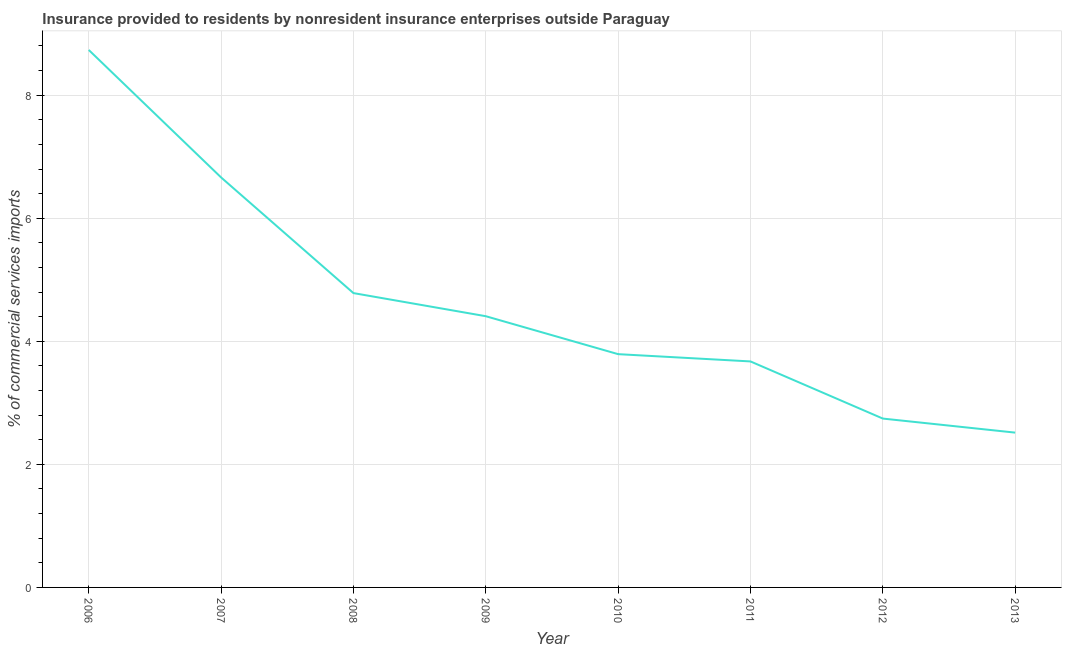What is the insurance provided by non-residents in 2013?
Offer a very short reply. 2.52. Across all years, what is the maximum insurance provided by non-residents?
Your response must be concise. 8.74. Across all years, what is the minimum insurance provided by non-residents?
Provide a succinct answer. 2.52. In which year was the insurance provided by non-residents minimum?
Offer a very short reply. 2013. What is the sum of the insurance provided by non-residents?
Offer a terse response. 37.32. What is the difference between the insurance provided by non-residents in 2006 and 2009?
Offer a terse response. 4.33. What is the average insurance provided by non-residents per year?
Give a very brief answer. 4.66. What is the median insurance provided by non-residents?
Offer a very short reply. 4.1. What is the ratio of the insurance provided by non-residents in 2006 to that in 2009?
Provide a succinct answer. 1.98. Is the insurance provided by non-residents in 2010 less than that in 2012?
Keep it short and to the point. No. What is the difference between the highest and the second highest insurance provided by non-residents?
Keep it short and to the point. 2.07. What is the difference between the highest and the lowest insurance provided by non-residents?
Provide a short and direct response. 6.22. How many years are there in the graph?
Make the answer very short. 8. What is the difference between two consecutive major ticks on the Y-axis?
Ensure brevity in your answer.  2. Are the values on the major ticks of Y-axis written in scientific E-notation?
Keep it short and to the point. No. Does the graph contain any zero values?
Your answer should be compact. No. Does the graph contain grids?
Keep it short and to the point. Yes. What is the title of the graph?
Your response must be concise. Insurance provided to residents by nonresident insurance enterprises outside Paraguay. What is the label or title of the Y-axis?
Your answer should be compact. % of commercial services imports. What is the % of commercial services imports in 2006?
Your response must be concise. 8.74. What is the % of commercial services imports in 2007?
Provide a short and direct response. 6.66. What is the % of commercial services imports of 2008?
Your answer should be compact. 4.78. What is the % of commercial services imports in 2009?
Your answer should be compact. 4.41. What is the % of commercial services imports of 2010?
Your response must be concise. 3.79. What is the % of commercial services imports in 2011?
Keep it short and to the point. 3.67. What is the % of commercial services imports of 2012?
Ensure brevity in your answer.  2.74. What is the % of commercial services imports of 2013?
Keep it short and to the point. 2.52. What is the difference between the % of commercial services imports in 2006 and 2007?
Your answer should be very brief. 2.07. What is the difference between the % of commercial services imports in 2006 and 2008?
Provide a short and direct response. 3.95. What is the difference between the % of commercial services imports in 2006 and 2009?
Your response must be concise. 4.33. What is the difference between the % of commercial services imports in 2006 and 2010?
Your answer should be very brief. 4.94. What is the difference between the % of commercial services imports in 2006 and 2011?
Keep it short and to the point. 5.06. What is the difference between the % of commercial services imports in 2006 and 2012?
Your response must be concise. 5.99. What is the difference between the % of commercial services imports in 2006 and 2013?
Your answer should be very brief. 6.22. What is the difference between the % of commercial services imports in 2007 and 2008?
Make the answer very short. 1.88. What is the difference between the % of commercial services imports in 2007 and 2009?
Provide a succinct answer. 2.26. What is the difference between the % of commercial services imports in 2007 and 2010?
Your answer should be compact. 2.87. What is the difference between the % of commercial services imports in 2007 and 2011?
Your answer should be compact. 2.99. What is the difference between the % of commercial services imports in 2007 and 2012?
Offer a very short reply. 3.92. What is the difference between the % of commercial services imports in 2007 and 2013?
Provide a succinct answer. 4.15. What is the difference between the % of commercial services imports in 2008 and 2009?
Your response must be concise. 0.38. What is the difference between the % of commercial services imports in 2008 and 2010?
Ensure brevity in your answer.  0.99. What is the difference between the % of commercial services imports in 2008 and 2011?
Give a very brief answer. 1.11. What is the difference between the % of commercial services imports in 2008 and 2012?
Make the answer very short. 2.04. What is the difference between the % of commercial services imports in 2008 and 2013?
Keep it short and to the point. 2.27. What is the difference between the % of commercial services imports in 2009 and 2010?
Give a very brief answer. 0.62. What is the difference between the % of commercial services imports in 2009 and 2011?
Your answer should be very brief. 0.74. What is the difference between the % of commercial services imports in 2009 and 2012?
Make the answer very short. 1.66. What is the difference between the % of commercial services imports in 2009 and 2013?
Make the answer very short. 1.89. What is the difference between the % of commercial services imports in 2010 and 2011?
Keep it short and to the point. 0.12. What is the difference between the % of commercial services imports in 2010 and 2012?
Provide a short and direct response. 1.05. What is the difference between the % of commercial services imports in 2010 and 2013?
Offer a very short reply. 1.28. What is the difference between the % of commercial services imports in 2011 and 2012?
Make the answer very short. 0.93. What is the difference between the % of commercial services imports in 2011 and 2013?
Give a very brief answer. 1.16. What is the difference between the % of commercial services imports in 2012 and 2013?
Offer a very short reply. 0.23. What is the ratio of the % of commercial services imports in 2006 to that in 2007?
Provide a succinct answer. 1.31. What is the ratio of the % of commercial services imports in 2006 to that in 2008?
Keep it short and to the point. 1.83. What is the ratio of the % of commercial services imports in 2006 to that in 2009?
Your answer should be compact. 1.98. What is the ratio of the % of commercial services imports in 2006 to that in 2010?
Provide a succinct answer. 2.3. What is the ratio of the % of commercial services imports in 2006 to that in 2011?
Your answer should be compact. 2.38. What is the ratio of the % of commercial services imports in 2006 to that in 2012?
Your response must be concise. 3.18. What is the ratio of the % of commercial services imports in 2006 to that in 2013?
Your answer should be very brief. 3.47. What is the ratio of the % of commercial services imports in 2007 to that in 2008?
Make the answer very short. 1.39. What is the ratio of the % of commercial services imports in 2007 to that in 2009?
Your response must be concise. 1.51. What is the ratio of the % of commercial services imports in 2007 to that in 2010?
Offer a very short reply. 1.76. What is the ratio of the % of commercial services imports in 2007 to that in 2011?
Your answer should be very brief. 1.81. What is the ratio of the % of commercial services imports in 2007 to that in 2012?
Your answer should be compact. 2.43. What is the ratio of the % of commercial services imports in 2007 to that in 2013?
Make the answer very short. 2.65. What is the ratio of the % of commercial services imports in 2008 to that in 2009?
Offer a terse response. 1.08. What is the ratio of the % of commercial services imports in 2008 to that in 2010?
Your response must be concise. 1.26. What is the ratio of the % of commercial services imports in 2008 to that in 2011?
Offer a very short reply. 1.3. What is the ratio of the % of commercial services imports in 2008 to that in 2012?
Your answer should be compact. 1.74. What is the ratio of the % of commercial services imports in 2008 to that in 2013?
Provide a succinct answer. 1.9. What is the ratio of the % of commercial services imports in 2009 to that in 2010?
Provide a short and direct response. 1.16. What is the ratio of the % of commercial services imports in 2009 to that in 2012?
Provide a short and direct response. 1.61. What is the ratio of the % of commercial services imports in 2009 to that in 2013?
Your answer should be compact. 1.75. What is the ratio of the % of commercial services imports in 2010 to that in 2011?
Give a very brief answer. 1.03. What is the ratio of the % of commercial services imports in 2010 to that in 2012?
Keep it short and to the point. 1.38. What is the ratio of the % of commercial services imports in 2010 to that in 2013?
Provide a succinct answer. 1.51. What is the ratio of the % of commercial services imports in 2011 to that in 2012?
Give a very brief answer. 1.34. What is the ratio of the % of commercial services imports in 2011 to that in 2013?
Provide a succinct answer. 1.46. What is the ratio of the % of commercial services imports in 2012 to that in 2013?
Provide a short and direct response. 1.09. 